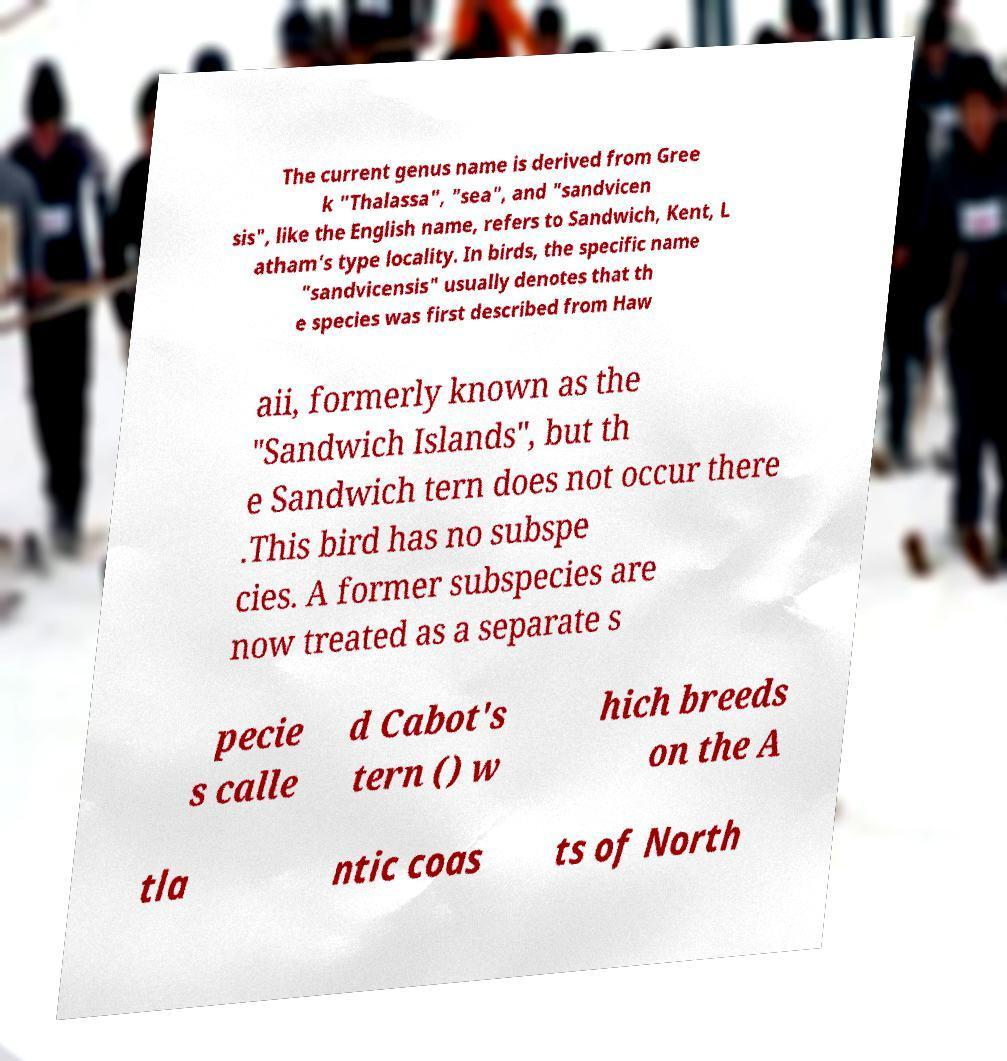Could you assist in decoding the text presented in this image and type it out clearly? The current genus name is derived from Gree k "Thalassa", "sea", and "sandvicen sis", like the English name, refers to Sandwich, Kent, L atham's type locality. In birds, the specific name "sandvicensis" usually denotes that th e species was first described from Haw aii, formerly known as the "Sandwich Islands", but th e Sandwich tern does not occur there .This bird has no subspe cies. A former subspecies are now treated as a separate s pecie s calle d Cabot's tern () w hich breeds on the A tla ntic coas ts of North 